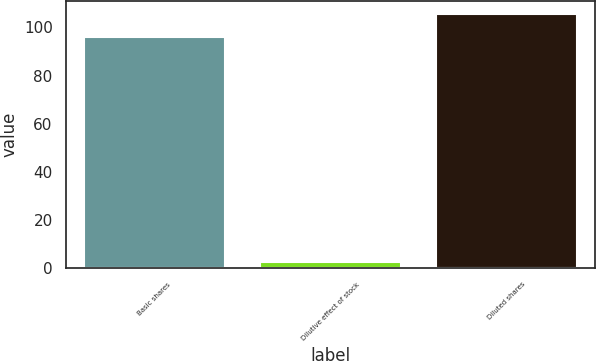Convert chart. <chart><loc_0><loc_0><loc_500><loc_500><bar_chart><fcel>Basic shares<fcel>Dilutive effect of stock<fcel>Diluted shares<nl><fcel>96<fcel>2.7<fcel>105.6<nl></chart> 